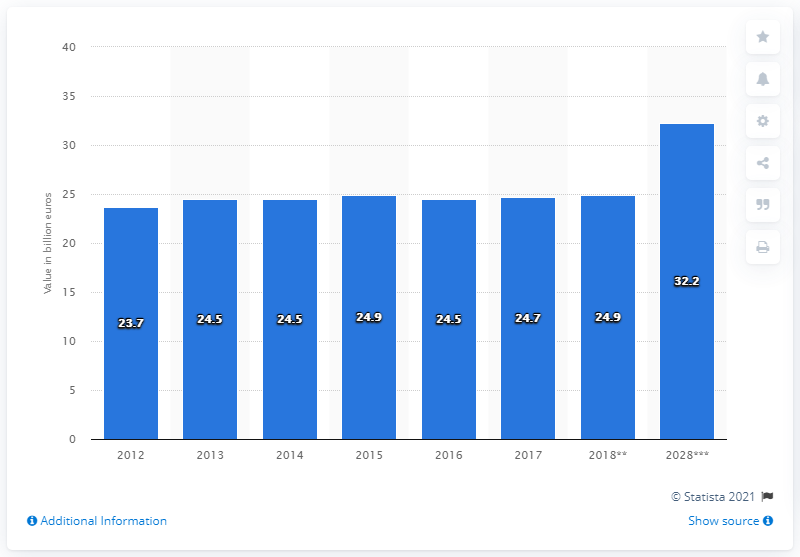Highlight a few significant elements in this photo. In 2017, the travel and tourism industry made a significant contribution to Belgium's Gross Domestic Product, contributing 24.9% to the country's overall economic output. 